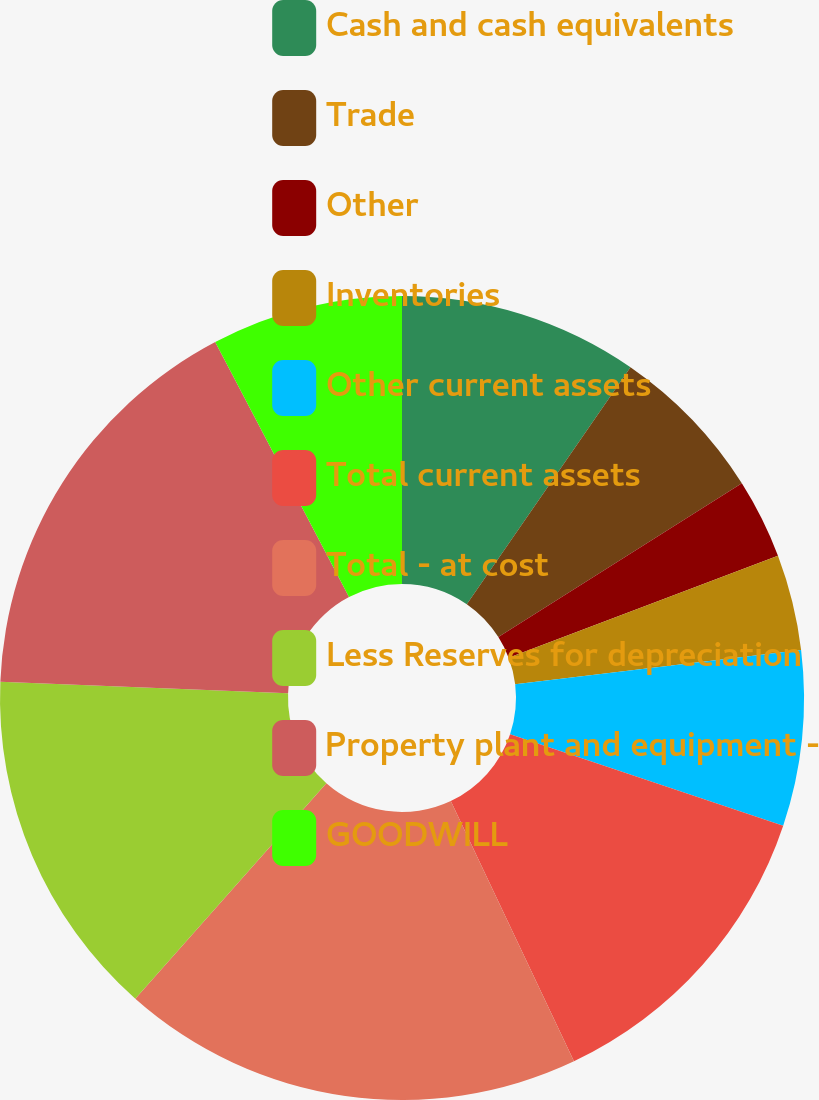Convert chart. <chart><loc_0><loc_0><loc_500><loc_500><pie_chart><fcel>Cash and cash equivalents<fcel>Trade<fcel>Other<fcel>Inventories<fcel>Other current assets<fcel>Total current assets<fcel>Total - at cost<fcel>Less Reserves for depreciation<fcel>Property plant and equipment -<fcel>GOODWILL<nl><fcel>9.62%<fcel>6.41%<fcel>3.21%<fcel>3.85%<fcel>7.05%<fcel>12.82%<fcel>18.58%<fcel>14.1%<fcel>16.66%<fcel>7.69%<nl></chart> 